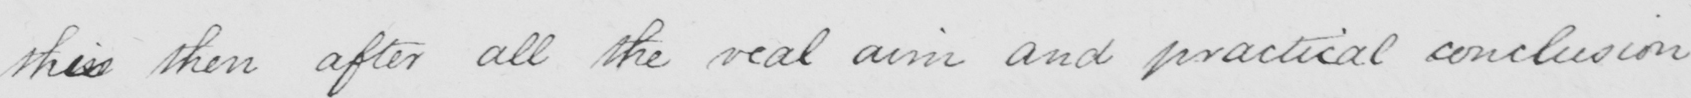Transcribe the text shown in this historical manuscript line. thenis then after all the real aim and practical conclusion 